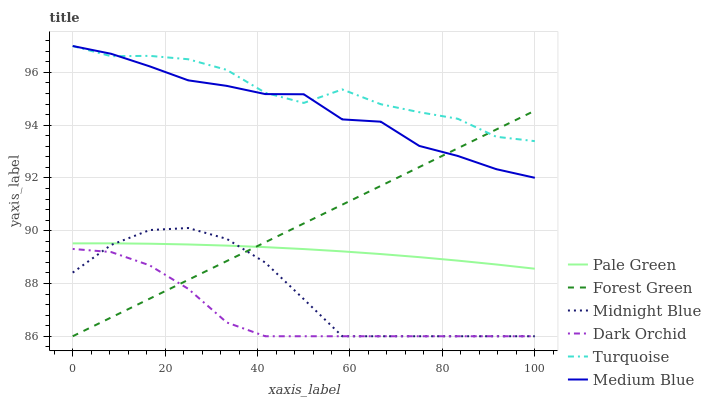Does Dark Orchid have the minimum area under the curve?
Answer yes or no. Yes. Does Turquoise have the maximum area under the curve?
Answer yes or no. Yes. Does Midnight Blue have the minimum area under the curve?
Answer yes or no. No. Does Midnight Blue have the maximum area under the curve?
Answer yes or no. No. Is Forest Green the smoothest?
Answer yes or no. Yes. Is Turquoise the roughest?
Answer yes or no. Yes. Is Midnight Blue the smoothest?
Answer yes or no. No. Is Midnight Blue the roughest?
Answer yes or no. No. Does Midnight Blue have the lowest value?
Answer yes or no. Yes. Does Medium Blue have the lowest value?
Answer yes or no. No. Does Medium Blue have the highest value?
Answer yes or no. Yes. Does Midnight Blue have the highest value?
Answer yes or no. No. Is Midnight Blue less than Turquoise?
Answer yes or no. Yes. Is Turquoise greater than Dark Orchid?
Answer yes or no. Yes. Does Pale Green intersect Midnight Blue?
Answer yes or no. Yes. Is Pale Green less than Midnight Blue?
Answer yes or no. No. Is Pale Green greater than Midnight Blue?
Answer yes or no. No. Does Midnight Blue intersect Turquoise?
Answer yes or no. No. 